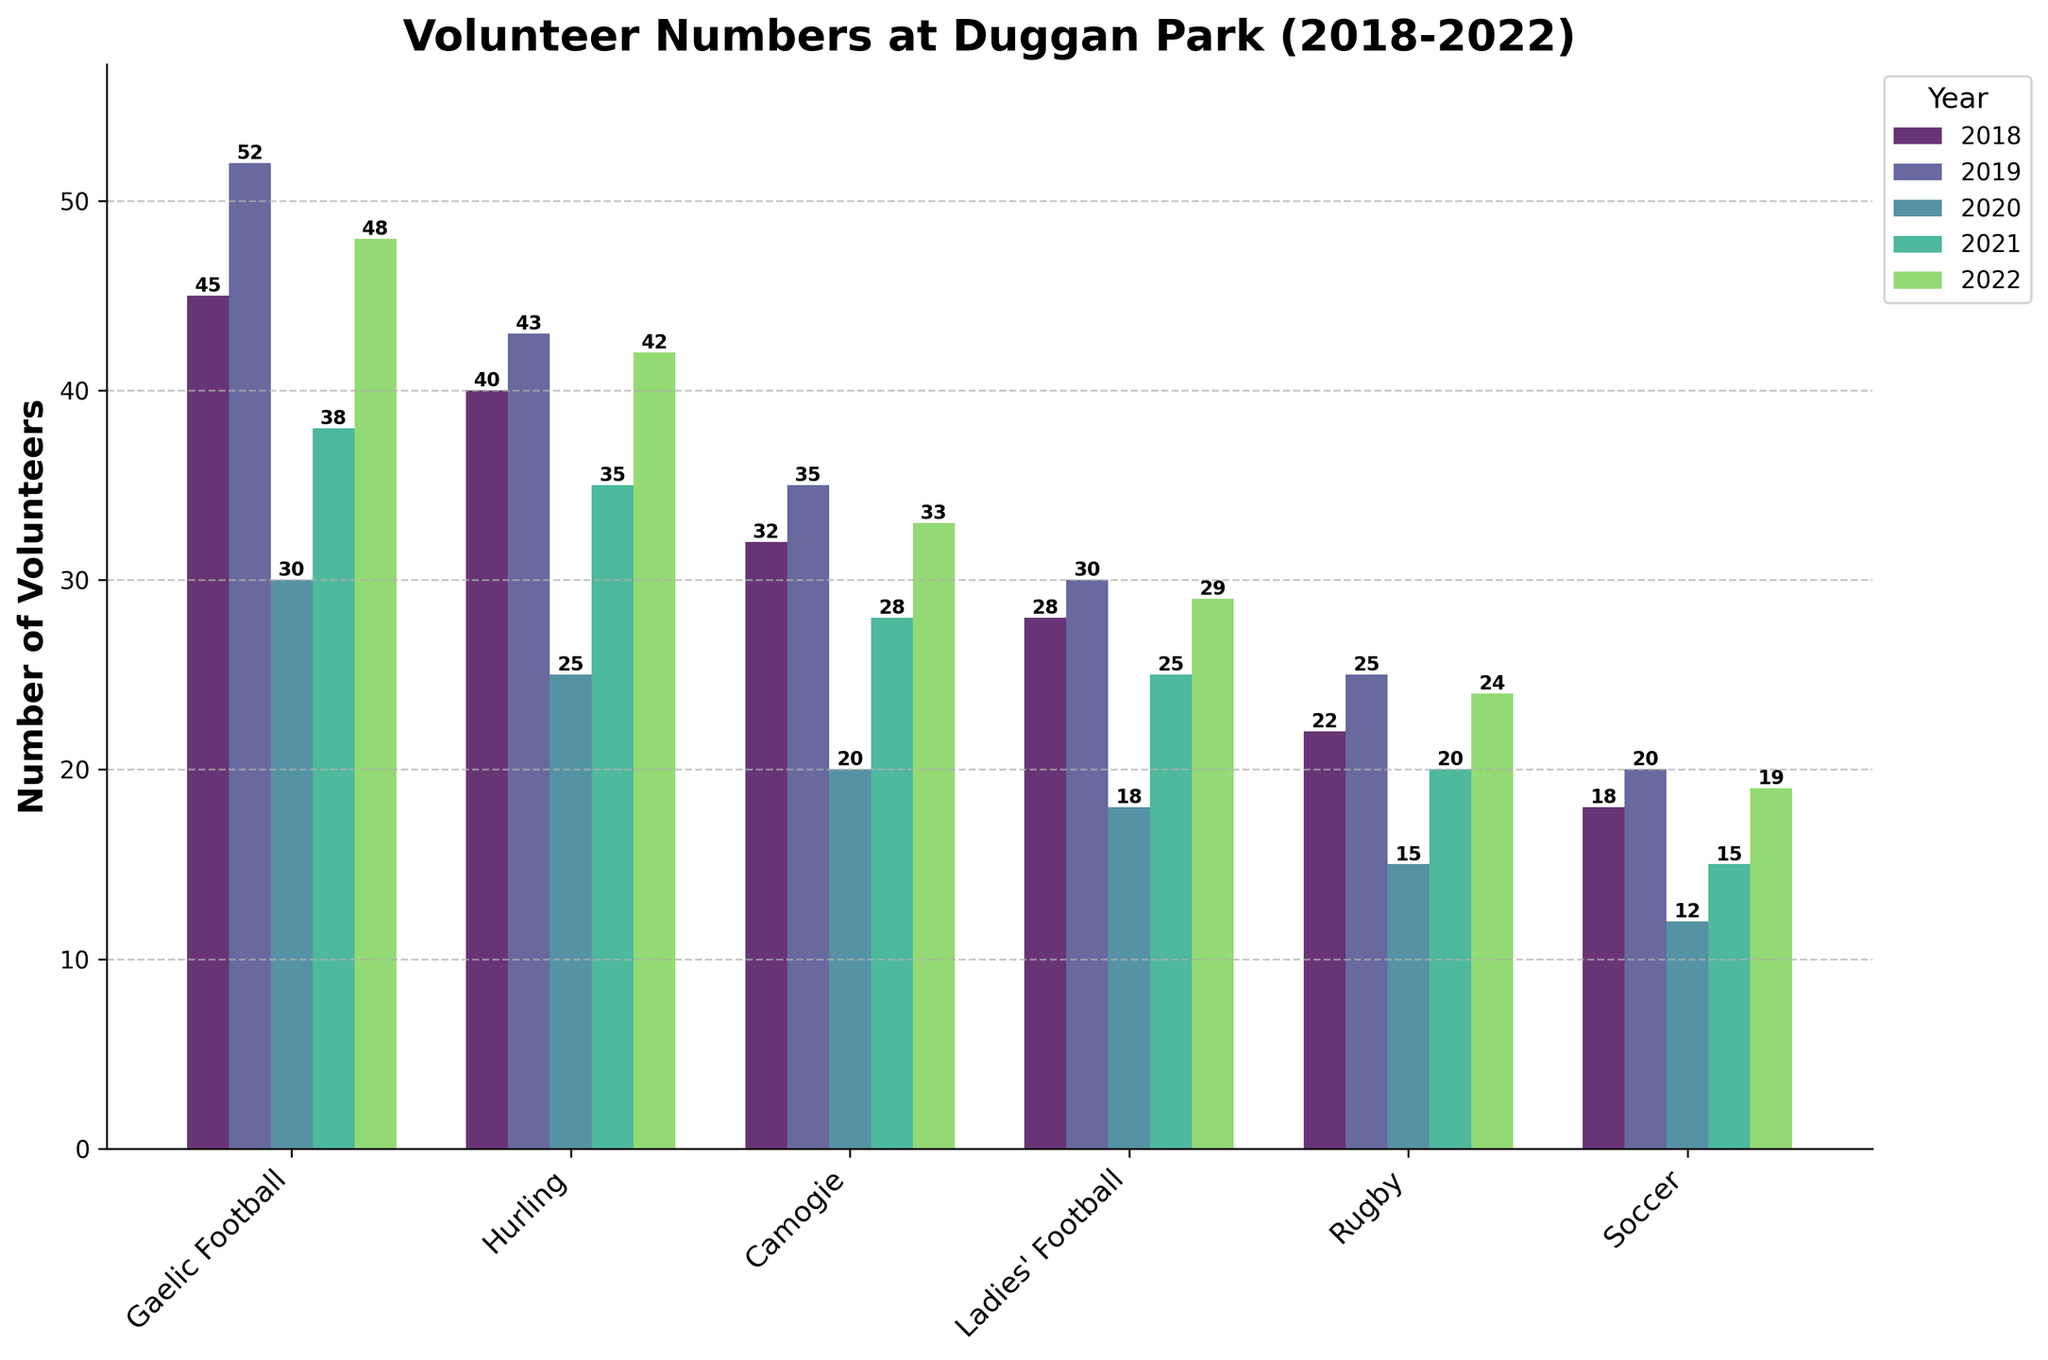Which sport had the highest number of volunteers in 2019? Check the height of the bars corresponding to each sport for the year 2019. Gaelic Football has the highest bar.
Answer: Gaelic Football During which year did Rugby have the fewest volunteers? Identify the shortest bar for Rugby across all years. The shortest bar is in 2020.
Answer: 2020 How many more volunteers were there for Hurling in 2018 compared to Soccer in 2019? Look at the bar heights for Hurling in 2018 and Soccer in 2019 and subtract the numbers. Hurling in 2018 had 40 volunteers and Soccer in 2019 had 20, so the difference is 40 - 20 = 20.
Answer: 20 Which sport experienced the largest drop in the number of volunteers from 2019 to 2020? Calculate the difference between the bar heights for each sport between 2019 and 2020 and find the sport with the biggest decrease. Camogie had a drop from 35 to 20, a decrease of 15 volunteers.
Answer: Camogie What is the average number of volunteers for Ladies' Football over the five years? Add up the number of volunteers for Ladies' Football over 2018, 2019, 2020, 2021, and 2022 and divide by 5. The sum is 28 + 30 + 18 + 25 + 29 = 130, so the average is 130 / 5 = 26.
Answer: 26 Which sports had a higher number of volunteers in 2022 compared to 2021? Compare the heights of the bars for each sport in 2022 and 2021. Gaelic Football, Hurling, Camogie, Ladies' Football, Rugby, and Soccer all had higher numbers in 2022 compared to 2021.
Answer: All sports How did the volunteer numbers for Gaelic Football change from 2018 to 2022? Note the height of the Gaelic Football bars for each year from 2018 to 2022. The numbers are 45, 52, 30, 38, and 48 respectively. It increased from 45 (2018) to 52 (2019), dropped to 30 (2020), increased to 38 (2021), and further increased to 48 (2022).
Answer: Increased, decreased, increased, increased Which year had the highest total number of volunteers across all sports? Sum the number of volunteers for each year across all sports and compare the totals. 2018: 45+40+32+28+22+18=185; 2019: 52+43+35+30+25+20=205; 2020: 30+25+20+18+15+12=120; 2021: 38+35+28+25+20+15=161; 2022: 48+42+33+29+24+19=195. 2019 had the highest total of 205 volunteers.
Answer: 2019 Which sport had the smallest variation in volunteer numbers over the five years? Observe the range of the bars' heights for each sport across the five years. Calculate the difference between the maximum and minimum volunteer numbers for each sport. The sport with the smallest range is Rugby, with a range of 25 - 15 = 10.
Answer: Rugby 